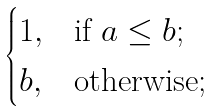<formula> <loc_0><loc_0><loc_500><loc_500>\begin{cases} 1 , & \text {if $a\leq b$;} \\ b , & \text {otherwise;} \end{cases}</formula> 